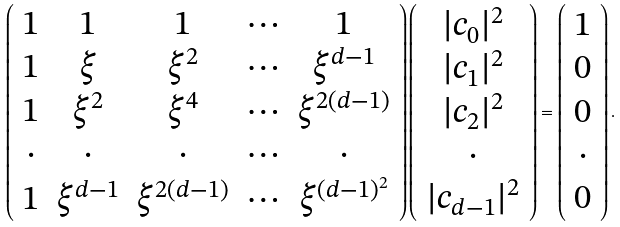<formula> <loc_0><loc_0><loc_500><loc_500>\left ( \begin{array} { c c c c c } 1 & 1 & 1 & \cdots & 1 \\ 1 & \xi & \xi ^ { 2 } & \cdots & \xi ^ { d - 1 } \\ 1 & \xi ^ { 2 } & \xi ^ { 4 } & \cdots & \xi ^ { 2 ( d - 1 ) } \\ \cdot & \cdot & \cdot & \cdots & \cdot \\ 1 & \xi ^ { d - 1 } & \xi ^ { 2 ( d - 1 ) } & \cdots & \xi ^ { ( d - 1 ) ^ { 2 } } \\ \end{array} \right ) \left ( \begin{array} { c } | c _ { 0 } | ^ { 2 } \\ | c _ { 1 } | ^ { 2 } \\ | c _ { 2 } | ^ { 2 } \\ \cdot \\ | c _ { d - 1 } | ^ { 2 } \end{array} \right ) = \left ( \begin{array} { c } 1 \\ 0 \\ 0 \\ \cdot \\ 0 \end{array} \right ) .</formula> 